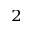<formula> <loc_0><loc_0><loc_500><loc_500>^ { 2 }</formula> 